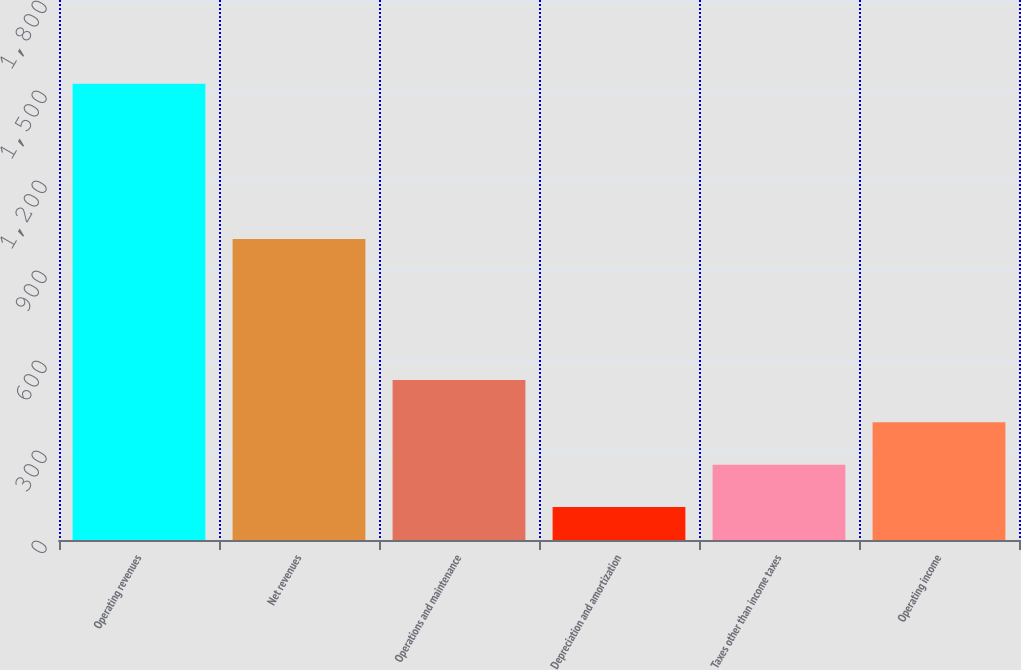Convert chart. <chart><loc_0><loc_0><loc_500><loc_500><bar_chart><fcel>Operating revenues<fcel>Net revenues<fcel>Operations and maintenance<fcel>Depreciation and amortization<fcel>Taxes other than income taxes<fcel>Operating income<nl><fcel>1521<fcel>1003<fcel>533.3<fcel>110<fcel>251.1<fcel>392.2<nl></chart> 